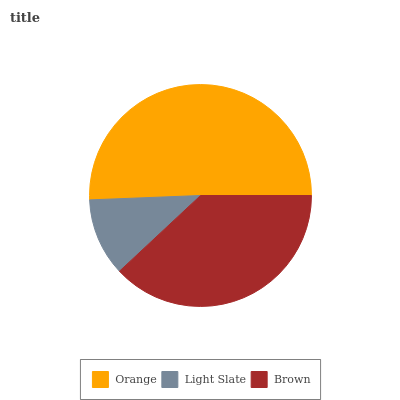Is Light Slate the minimum?
Answer yes or no. Yes. Is Orange the maximum?
Answer yes or no. Yes. Is Brown the minimum?
Answer yes or no. No. Is Brown the maximum?
Answer yes or no. No. Is Brown greater than Light Slate?
Answer yes or no. Yes. Is Light Slate less than Brown?
Answer yes or no. Yes. Is Light Slate greater than Brown?
Answer yes or no. No. Is Brown less than Light Slate?
Answer yes or no. No. Is Brown the high median?
Answer yes or no. Yes. Is Brown the low median?
Answer yes or no. Yes. Is Orange the high median?
Answer yes or no. No. Is Orange the low median?
Answer yes or no. No. 